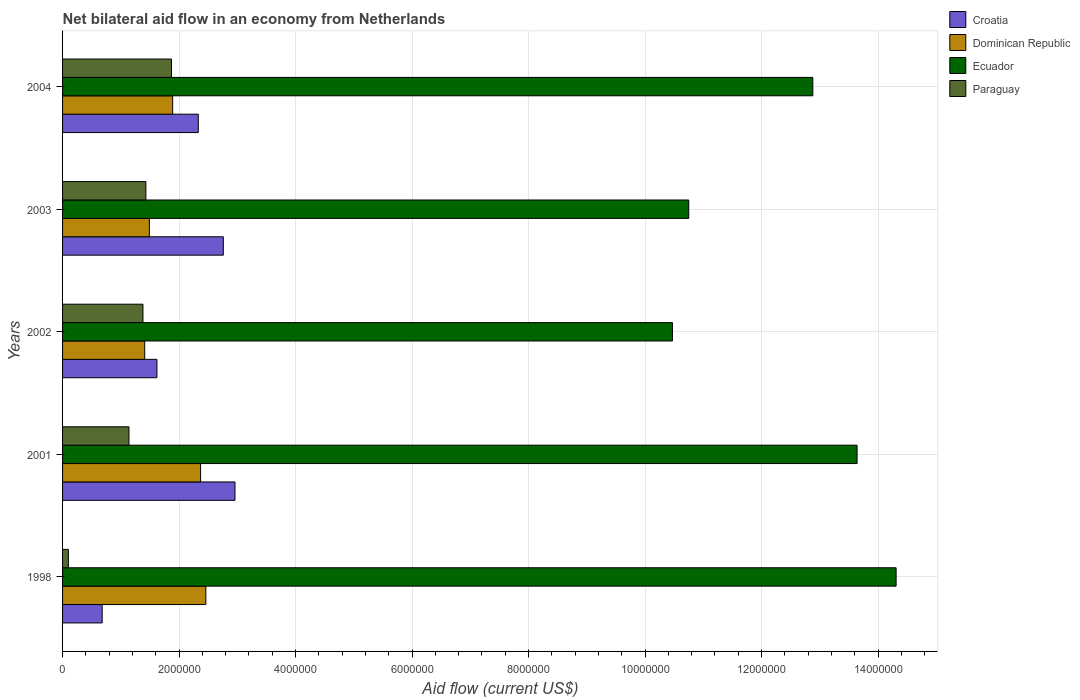How many different coloured bars are there?
Your response must be concise. 4. Are the number of bars per tick equal to the number of legend labels?
Your answer should be very brief. Yes. How many bars are there on the 5th tick from the bottom?
Give a very brief answer. 4. What is the net bilateral aid flow in Paraguay in 2004?
Provide a succinct answer. 1.87e+06. Across all years, what is the maximum net bilateral aid flow in Croatia?
Offer a terse response. 2.96e+06. Across all years, what is the minimum net bilateral aid flow in Dominican Republic?
Keep it short and to the point. 1.41e+06. In which year was the net bilateral aid flow in Ecuador maximum?
Offer a terse response. 1998. What is the total net bilateral aid flow in Ecuador in the graph?
Provide a short and direct response. 6.20e+07. What is the difference between the net bilateral aid flow in Paraguay in 1998 and that in 2003?
Your answer should be very brief. -1.33e+06. What is the difference between the net bilateral aid flow in Ecuador in 1998 and the net bilateral aid flow in Croatia in 2002?
Your answer should be very brief. 1.27e+07. What is the average net bilateral aid flow in Ecuador per year?
Offer a terse response. 1.24e+07. In the year 1998, what is the difference between the net bilateral aid flow in Paraguay and net bilateral aid flow in Ecuador?
Make the answer very short. -1.42e+07. In how many years, is the net bilateral aid flow in Croatia greater than 6800000 US$?
Offer a very short reply. 0. What is the ratio of the net bilateral aid flow in Croatia in 2003 to that in 2004?
Ensure brevity in your answer.  1.18. Is the net bilateral aid flow in Paraguay in 1998 less than that in 2003?
Your answer should be very brief. Yes. What is the difference between the highest and the second highest net bilateral aid flow in Croatia?
Your answer should be very brief. 2.00e+05. What is the difference between the highest and the lowest net bilateral aid flow in Ecuador?
Offer a terse response. 3.84e+06. In how many years, is the net bilateral aid flow in Ecuador greater than the average net bilateral aid flow in Ecuador taken over all years?
Make the answer very short. 3. Is the sum of the net bilateral aid flow in Croatia in 2001 and 2004 greater than the maximum net bilateral aid flow in Paraguay across all years?
Your answer should be very brief. Yes. What does the 3rd bar from the top in 1998 represents?
Ensure brevity in your answer.  Dominican Republic. What does the 2nd bar from the bottom in 1998 represents?
Offer a terse response. Dominican Republic. Is it the case that in every year, the sum of the net bilateral aid flow in Dominican Republic and net bilateral aid flow in Croatia is greater than the net bilateral aid flow in Paraguay?
Make the answer very short. Yes. Are all the bars in the graph horizontal?
Your response must be concise. Yes. How many years are there in the graph?
Keep it short and to the point. 5. What is the difference between two consecutive major ticks on the X-axis?
Offer a terse response. 2.00e+06. Are the values on the major ticks of X-axis written in scientific E-notation?
Offer a very short reply. No. How are the legend labels stacked?
Your answer should be compact. Vertical. What is the title of the graph?
Make the answer very short. Net bilateral aid flow in an economy from Netherlands. Does "Myanmar" appear as one of the legend labels in the graph?
Your answer should be compact. No. What is the label or title of the Y-axis?
Provide a short and direct response. Years. What is the Aid flow (current US$) in Croatia in 1998?
Your response must be concise. 6.80e+05. What is the Aid flow (current US$) of Dominican Republic in 1998?
Your answer should be very brief. 2.46e+06. What is the Aid flow (current US$) in Ecuador in 1998?
Give a very brief answer. 1.43e+07. What is the Aid flow (current US$) in Croatia in 2001?
Keep it short and to the point. 2.96e+06. What is the Aid flow (current US$) of Dominican Republic in 2001?
Offer a very short reply. 2.37e+06. What is the Aid flow (current US$) in Ecuador in 2001?
Keep it short and to the point. 1.36e+07. What is the Aid flow (current US$) in Paraguay in 2001?
Provide a succinct answer. 1.14e+06. What is the Aid flow (current US$) in Croatia in 2002?
Keep it short and to the point. 1.62e+06. What is the Aid flow (current US$) in Dominican Republic in 2002?
Provide a succinct answer. 1.41e+06. What is the Aid flow (current US$) in Ecuador in 2002?
Your answer should be compact. 1.05e+07. What is the Aid flow (current US$) in Paraguay in 2002?
Provide a short and direct response. 1.38e+06. What is the Aid flow (current US$) of Croatia in 2003?
Give a very brief answer. 2.76e+06. What is the Aid flow (current US$) of Dominican Republic in 2003?
Offer a terse response. 1.49e+06. What is the Aid flow (current US$) in Ecuador in 2003?
Make the answer very short. 1.08e+07. What is the Aid flow (current US$) of Paraguay in 2003?
Provide a short and direct response. 1.43e+06. What is the Aid flow (current US$) of Croatia in 2004?
Your answer should be compact. 2.33e+06. What is the Aid flow (current US$) in Dominican Republic in 2004?
Make the answer very short. 1.89e+06. What is the Aid flow (current US$) in Ecuador in 2004?
Keep it short and to the point. 1.29e+07. What is the Aid flow (current US$) of Paraguay in 2004?
Make the answer very short. 1.87e+06. Across all years, what is the maximum Aid flow (current US$) of Croatia?
Your answer should be compact. 2.96e+06. Across all years, what is the maximum Aid flow (current US$) in Dominican Republic?
Give a very brief answer. 2.46e+06. Across all years, what is the maximum Aid flow (current US$) of Ecuador?
Give a very brief answer. 1.43e+07. Across all years, what is the maximum Aid flow (current US$) in Paraguay?
Make the answer very short. 1.87e+06. Across all years, what is the minimum Aid flow (current US$) of Croatia?
Keep it short and to the point. 6.80e+05. Across all years, what is the minimum Aid flow (current US$) in Dominican Republic?
Your answer should be compact. 1.41e+06. Across all years, what is the minimum Aid flow (current US$) in Ecuador?
Provide a succinct answer. 1.05e+07. What is the total Aid flow (current US$) of Croatia in the graph?
Ensure brevity in your answer.  1.04e+07. What is the total Aid flow (current US$) in Dominican Republic in the graph?
Give a very brief answer. 9.62e+06. What is the total Aid flow (current US$) in Ecuador in the graph?
Provide a succinct answer. 6.20e+07. What is the total Aid flow (current US$) of Paraguay in the graph?
Provide a succinct answer. 5.92e+06. What is the difference between the Aid flow (current US$) in Croatia in 1998 and that in 2001?
Give a very brief answer. -2.28e+06. What is the difference between the Aid flow (current US$) of Ecuador in 1998 and that in 2001?
Make the answer very short. 6.70e+05. What is the difference between the Aid flow (current US$) of Paraguay in 1998 and that in 2001?
Provide a succinct answer. -1.04e+06. What is the difference between the Aid flow (current US$) of Croatia in 1998 and that in 2002?
Your answer should be very brief. -9.40e+05. What is the difference between the Aid flow (current US$) of Dominican Republic in 1998 and that in 2002?
Your answer should be very brief. 1.05e+06. What is the difference between the Aid flow (current US$) of Ecuador in 1998 and that in 2002?
Your response must be concise. 3.84e+06. What is the difference between the Aid flow (current US$) of Paraguay in 1998 and that in 2002?
Offer a terse response. -1.28e+06. What is the difference between the Aid flow (current US$) of Croatia in 1998 and that in 2003?
Offer a very short reply. -2.08e+06. What is the difference between the Aid flow (current US$) of Dominican Republic in 1998 and that in 2003?
Keep it short and to the point. 9.70e+05. What is the difference between the Aid flow (current US$) in Ecuador in 1998 and that in 2003?
Give a very brief answer. 3.56e+06. What is the difference between the Aid flow (current US$) of Paraguay in 1998 and that in 2003?
Your answer should be compact. -1.33e+06. What is the difference between the Aid flow (current US$) of Croatia in 1998 and that in 2004?
Ensure brevity in your answer.  -1.65e+06. What is the difference between the Aid flow (current US$) in Dominican Republic in 1998 and that in 2004?
Offer a very short reply. 5.70e+05. What is the difference between the Aid flow (current US$) in Ecuador in 1998 and that in 2004?
Provide a succinct answer. 1.43e+06. What is the difference between the Aid flow (current US$) in Paraguay in 1998 and that in 2004?
Provide a short and direct response. -1.77e+06. What is the difference between the Aid flow (current US$) of Croatia in 2001 and that in 2002?
Your response must be concise. 1.34e+06. What is the difference between the Aid flow (current US$) in Dominican Republic in 2001 and that in 2002?
Provide a short and direct response. 9.60e+05. What is the difference between the Aid flow (current US$) of Ecuador in 2001 and that in 2002?
Give a very brief answer. 3.17e+06. What is the difference between the Aid flow (current US$) in Dominican Republic in 2001 and that in 2003?
Make the answer very short. 8.80e+05. What is the difference between the Aid flow (current US$) of Ecuador in 2001 and that in 2003?
Provide a short and direct response. 2.89e+06. What is the difference between the Aid flow (current US$) of Croatia in 2001 and that in 2004?
Offer a very short reply. 6.30e+05. What is the difference between the Aid flow (current US$) in Dominican Republic in 2001 and that in 2004?
Ensure brevity in your answer.  4.80e+05. What is the difference between the Aid flow (current US$) of Ecuador in 2001 and that in 2004?
Keep it short and to the point. 7.60e+05. What is the difference between the Aid flow (current US$) in Paraguay in 2001 and that in 2004?
Offer a terse response. -7.30e+05. What is the difference between the Aid flow (current US$) of Croatia in 2002 and that in 2003?
Your response must be concise. -1.14e+06. What is the difference between the Aid flow (current US$) of Ecuador in 2002 and that in 2003?
Offer a terse response. -2.80e+05. What is the difference between the Aid flow (current US$) of Paraguay in 2002 and that in 2003?
Provide a succinct answer. -5.00e+04. What is the difference between the Aid flow (current US$) of Croatia in 2002 and that in 2004?
Your answer should be very brief. -7.10e+05. What is the difference between the Aid flow (current US$) in Dominican Republic in 2002 and that in 2004?
Your answer should be very brief. -4.80e+05. What is the difference between the Aid flow (current US$) of Ecuador in 2002 and that in 2004?
Offer a very short reply. -2.41e+06. What is the difference between the Aid flow (current US$) in Paraguay in 2002 and that in 2004?
Provide a succinct answer. -4.90e+05. What is the difference between the Aid flow (current US$) of Dominican Republic in 2003 and that in 2004?
Provide a succinct answer. -4.00e+05. What is the difference between the Aid flow (current US$) of Ecuador in 2003 and that in 2004?
Provide a succinct answer. -2.13e+06. What is the difference between the Aid flow (current US$) of Paraguay in 2003 and that in 2004?
Give a very brief answer. -4.40e+05. What is the difference between the Aid flow (current US$) in Croatia in 1998 and the Aid flow (current US$) in Dominican Republic in 2001?
Give a very brief answer. -1.69e+06. What is the difference between the Aid flow (current US$) of Croatia in 1998 and the Aid flow (current US$) of Ecuador in 2001?
Offer a terse response. -1.30e+07. What is the difference between the Aid flow (current US$) of Croatia in 1998 and the Aid flow (current US$) of Paraguay in 2001?
Your answer should be very brief. -4.60e+05. What is the difference between the Aid flow (current US$) in Dominican Republic in 1998 and the Aid flow (current US$) in Ecuador in 2001?
Provide a succinct answer. -1.12e+07. What is the difference between the Aid flow (current US$) of Dominican Republic in 1998 and the Aid flow (current US$) of Paraguay in 2001?
Provide a succinct answer. 1.32e+06. What is the difference between the Aid flow (current US$) of Ecuador in 1998 and the Aid flow (current US$) of Paraguay in 2001?
Offer a terse response. 1.32e+07. What is the difference between the Aid flow (current US$) of Croatia in 1998 and the Aid flow (current US$) of Dominican Republic in 2002?
Your answer should be compact. -7.30e+05. What is the difference between the Aid flow (current US$) in Croatia in 1998 and the Aid flow (current US$) in Ecuador in 2002?
Give a very brief answer. -9.79e+06. What is the difference between the Aid flow (current US$) of Croatia in 1998 and the Aid flow (current US$) of Paraguay in 2002?
Make the answer very short. -7.00e+05. What is the difference between the Aid flow (current US$) in Dominican Republic in 1998 and the Aid flow (current US$) in Ecuador in 2002?
Provide a short and direct response. -8.01e+06. What is the difference between the Aid flow (current US$) in Dominican Republic in 1998 and the Aid flow (current US$) in Paraguay in 2002?
Give a very brief answer. 1.08e+06. What is the difference between the Aid flow (current US$) in Ecuador in 1998 and the Aid flow (current US$) in Paraguay in 2002?
Provide a short and direct response. 1.29e+07. What is the difference between the Aid flow (current US$) in Croatia in 1998 and the Aid flow (current US$) in Dominican Republic in 2003?
Your response must be concise. -8.10e+05. What is the difference between the Aid flow (current US$) in Croatia in 1998 and the Aid flow (current US$) in Ecuador in 2003?
Provide a short and direct response. -1.01e+07. What is the difference between the Aid flow (current US$) of Croatia in 1998 and the Aid flow (current US$) of Paraguay in 2003?
Your response must be concise. -7.50e+05. What is the difference between the Aid flow (current US$) of Dominican Republic in 1998 and the Aid flow (current US$) of Ecuador in 2003?
Offer a very short reply. -8.29e+06. What is the difference between the Aid flow (current US$) of Dominican Republic in 1998 and the Aid flow (current US$) of Paraguay in 2003?
Your response must be concise. 1.03e+06. What is the difference between the Aid flow (current US$) of Ecuador in 1998 and the Aid flow (current US$) of Paraguay in 2003?
Provide a short and direct response. 1.29e+07. What is the difference between the Aid flow (current US$) in Croatia in 1998 and the Aid flow (current US$) in Dominican Republic in 2004?
Ensure brevity in your answer.  -1.21e+06. What is the difference between the Aid flow (current US$) in Croatia in 1998 and the Aid flow (current US$) in Ecuador in 2004?
Offer a very short reply. -1.22e+07. What is the difference between the Aid flow (current US$) of Croatia in 1998 and the Aid flow (current US$) of Paraguay in 2004?
Your answer should be compact. -1.19e+06. What is the difference between the Aid flow (current US$) in Dominican Republic in 1998 and the Aid flow (current US$) in Ecuador in 2004?
Give a very brief answer. -1.04e+07. What is the difference between the Aid flow (current US$) in Dominican Republic in 1998 and the Aid flow (current US$) in Paraguay in 2004?
Your response must be concise. 5.90e+05. What is the difference between the Aid flow (current US$) in Ecuador in 1998 and the Aid flow (current US$) in Paraguay in 2004?
Ensure brevity in your answer.  1.24e+07. What is the difference between the Aid flow (current US$) of Croatia in 2001 and the Aid flow (current US$) of Dominican Republic in 2002?
Ensure brevity in your answer.  1.55e+06. What is the difference between the Aid flow (current US$) of Croatia in 2001 and the Aid flow (current US$) of Ecuador in 2002?
Keep it short and to the point. -7.51e+06. What is the difference between the Aid flow (current US$) in Croatia in 2001 and the Aid flow (current US$) in Paraguay in 2002?
Your answer should be compact. 1.58e+06. What is the difference between the Aid flow (current US$) of Dominican Republic in 2001 and the Aid flow (current US$) of Ecuador in 2002?
Offer a very short reply. -8.10e+06. What is the difference between the Aid flow (current US$) of Dominican Republic in 2001 and the Aid flow (current US$) of Paraguay in 2002?
Provide a succinct answer. 9.90e+05. What is the difference between the Aid flow (current US$) of Ecuador in 2001 and the Aid flow (current US$) of Paraguay in 2002?
Keep it short and to the point. 1.23e+07. What is the difference between the Aid flow (current US$) of Croatia in 2001 and the Aid flow (current US$) of Dominican Republic in 2003?
Keep it short and to the point. 1.47e+06. What is the difference between the Aid flow (current US$) in Croatia in 2001 and the Aid flow (current US$) in Ecuador in 2003?
Your answer should be very brief. -7.79e+06. What is the difference between the Aid flow (current US$) in Croatia in 2001 and the Aid flow (current US$) in Paraguay in 2003?
Your answer should be very brief. 1.53e+06. What is the difference between the Aid flow (current US$) in Dominican Republic in 2001 and the Aid flow (current US$) in Ecuador in 2003?
Your answer should be compact. -8.38e+06. What is the difference between the Aid flow (current US$) of Dominican Republic in 2001 and the Aid flow (current US$) of Paraguay in 2003?
Provide a succinct answer. 9.40e+05. What is the difference between the Aid flow (current US$) of Ecuador in 2001 and the Aid flow (current US$) of Paraguay in 2003?
Ensure brevity in your answer.  1.22e+07. What is the difference between the Aid flow (current US$) of Croatia in 2001 and the Aid flow (current US$) of Dominican Republic in 2004?
Offer a terse response. 1.07e+06. What is the difference between the Aid flow (current US$) of Croatia in 2001 and the Aid flow (current US$) of Ecuador in 2004?
Offer a terse response. -9.92e+06. What is the difference between the Aid flow (current US$) of Croatia in 2001 and the Aid flow (current US$) of Paraguay in 2004?
Ensure brevity in your answer.  1.09e+06. What is the difference between the Aid flow (current US$) of Dominican Republic in 2001 and the Aid flow (current US$) of Ecuador in 2004?
Your response must be concise. -1.05e+07. What is the difference between the Aid flow (current US$) in Ecuador in 2001 and the Aid flow (current US$) in Paraguay in 2004?
Make the answer very short. 1.18e+07. What is the difference between the Aid flow (current US$) in Croatia in 2002 and the Aid flow (current US$) in Ecuador in 2003?
Provide a succinct answer. -9.13e+06. What is the difference between the Aid flow (current US$) of Dominican Republic in 2002 and the Aid flow (current US$) of Ecuador in 2003?
Ensure brevity in your answer.  -9.34e+06. What is the difference between the Aid flow (current US$) of Dominican Republic in 2002 and the Aid flow (current US$) of Paraguay in 2003?
Give a very brief answer. -2.00e+04. What is the difference between the Aid flow (current US$) in Ecuador in 2002 and the Aid flow (current US$) in Paraguay in 2003?
Keep it short and to the point. 9.04e+06. What is the difference between the Aid flow (current US$) of Croatia in 2002 and the Aid flow (current US$) of Dominican Republic in 2004?
Provide a short and direct response. -2.70e+05. What is the difference between the Aid flow (current US$) in Croatia in 2002 and the Aid flow (current US$) in Ecuador in 2004?
Keep it short and to the point. -1.13e+07. What is the difference between the Aid flow (current US$) in Croatia in 2002 and the Aid flow (current US$) in Paraguay in 2004?
Give a very brief answer. -2.50e+05. What is the difference between the Aid flow (current US$) in Dominican Republic in 2002 and the Aid flow (current US$) in Ecuador in 2004?
Your answer should be compact. -1.15e+07. What is the difference between the Aid flow (current US$) in Dominican Republic in 2002 and the Aid flow (current US$) in Paraguay in 2004?
Make the answer very short. -4.60e+05. What is the difference between the Aid flow (current US$) in Ecuador in 2002 and the Aid flow (current US$) in Paraguay in 2004?
Make the answer very short. 8.60e+06. What is the difference between the Aid flow (current US$) in Croatia in 2003 and the Aid flow (current US$) in Dominican Republic in 2004?
Keep it short and to the point. 8.70e+05. What is the difference between the Aid flow (current US$) of Croatia in 2003 and the Aid flow (current US$) of Ecuador in 2004?
Ensure brevity in your answer.  -1.01e+07. What is the difference between the Aid flow (current US$) of Croatia in 2003 and the Aid flow (current US$) of Paraguay in 2004?
Give a very brief answer. 8.90e+05. What is the difference between the Aid flow (current US$) of Dominican Republic in 2003 and the Aid flow (current US$) of Ecuador in 2004?
Your response must be concise. -1.14e+07. What is the difference between the Aid flow (current US$) of Dominican Republic in 2003 and the Aid flow (current US$) of Paraguay in 2004?
Make the answer very short. -3.80e+05. What is the difference between the Aid flow (current US$) in Ecuador in 2003 and the Aid flow (current US$) in Paraguay in 2004?
Keep it short and to the point. 8.88e+06. What is the average Aid flow (current US$) in Croatia per year?
Give a very brief answer. 2.07e+06. What is the average Aid flow (current US$) of Dominican Republic per year?
Your response must be concise. 1.92e+06. What is the average Aid flow (current US$) of Ecuador per year?
Give a very brief answer. 1.24e+07. What is the average Aid flow (current US$) in Paraguay per year?
Give a very brief answer. 1.18e+06. In the year 1998, what is the difference between the Aid flow (current US$) of Croatia and Aid flow (current US$) of Dominican Republic?
Make the answer very short. -1.78e+06. In the year 1998, what is the difference between the Aid flow (current US$) of Croatia and Aid flow (current US$) of Ecuador?
Your answer should be compact. -1.36e+07. In the year 1998, what is the difference between the Aid flow (current US$) in Croatia and Aid flow (current US$) in Paraguay?
Provide a succinct answer. 5.80e+05. In the year 1998, what is the difference between the Aid flow (current US$) of Dominican Republic and Aid flow (current US$) of Ecuador?
Give a very brief answer. -1.18e+07. In the year 1998, what is the difference between the Aid flow (current US$) of Dominican Republic and Aid flow (current US$) of Paraguay?
Offer a terse response. 2.36e+06. In the year 1998, what is the difference between the Aid flow (current US$) in Ecuador and Aid flow (current US$) in Paraguay?
Ensure brevity in your answer.  1.42e+07. In the year 2001, what is the difference between the Aid flow (current US$) in Croatia and Aid flow (current US$) in Dominican Republic?
Your answer should be very brief. 5.90e+05. In the year 2001, what is the difference between the Aid flow (current US$) in Croatia and Aid flow (current US$) in Ecuador?
Provide a short and direct response. -1.07e+07. In the year 2001, what is the difference between the Aid flow (current US$) of Croatia and Aid flow (current US$) of Paraguay?
Keep it short and to the point. 1.82e+06. In the year 2001, what is the difference between the Aid flow (current US$) in Dominican Republic and Aid flow (current US$) in Ecuador?
Your response must be concise. -1.13e+07. In the year 2001, what is the difference between the Aid flow (current US$) in Dominican Republic and Aid flow (current US$) in Paraguay?
Your answer should be compact. 1.23e+06. In the year 2001, what is the difference between the Aid flow (current US$) in Ecuador and Aid flow (current US$) in Paraguay?
Your response must be concise. 1.25e+07. In the year 2002, what is the difference between the Aid flow (current US$) of Croatia and Aid flow (current US$) of Ecuador?
Give a very brief answer. -8.85e+06. In the year 2002, what is the difference between the Aid flow (current US$) of Croatia and Aid flow (current US$) of Paraguay?
Provide a short and direct response. 2.40e+05. In the year 2002, what is the difference between the Aid flow (current US$) of Dominican Republic and Aid flow (current US$) of Ecuador?
Give a very brief answer. -9.06e+06. In the year 2002, what is the difference between the Aid flow (current US$) in Ecuador and Aid flow (current US$) in Paraguay?
Make the answer very short. 9.09e+06. In the year 2003, what is the difference between the Aid flow (current US$) of Croatia and Aid flow (current US$) of Dominican Republic?
Provide a short and direct response. 1.27e+06. In the year 2003, what is the difference between the Aid flow (current US$) of Croatia and Aid flow (current US$) of Ecuador?
Your response must be concise. -7.99e+06. In the year 2003, what is the difference between the Aid flow (current US$) in Croatia and Aid flow (current US$) in Paraguay?
Your answer should be compact. 1.33e+06. In the year 2003, what is the difference between the Aid flow (current US$) in Dominican Republic and Aid flow (current US$) in Ecuador?
Offer a terse response. -9.26e+06. In the year 2003, what is the difference between the Aid flow (current US$) of Ecuador and Aid flow (current US$) of Paraguay?
Offer a terse response. 9.32e+06. In the year 2004, what is the difference between the Aid flow (current US$) in Croatia and Aid flow (current US$) in Dominican Republic?
Give a very brief answer. 4.40e+05. In the year 2004, what is the difference between the Aid flow (current US$) of Croatia and Aid flow (current US$) of Ecuador?
Your answer should be compact. -1.06e+07. In the year 2004, what is the difference between the Aid flow (current US$) of Croatia and Aid flow (current US$) of Paraguay?
Your answer should be compact. 4.60e+05. In the year 2004, what is the difference between the Aid flow (current US$) in Dominican Republic and Aid flow (current US$) in Ecuador?
Provide a succinct answer. -1.10e+07. In the year 2004, what is the difference between the Aid flow (current US$) in Dominican Republic and Aid flow (current US$) in Paraguay?
Ensure brevity in your answer.  2.00e+04. In the year 2004, what is the difference between the Aid flow (current US$) in Ecuador and Aid flow (current US$) in Paraguay?
Offer a terse response. 1.10e+07. What is the ratio of the Aid flow (current US$) in Croatia in 1998 to that in 2001?
Provide a short and direct response. 0.23. What is the ratio of the Aid flow (current US$) of Dominican Republic in 1998 to that in 2001?
Your answer should be compact. 1.04. What is the ratio of the Aid flow (current US$) of Ecuador in 1998 to that in 2001?
Provide a short and direct response. 1.05. What is the ratio of the Aid flow (current US$) in Paraguay in 1998 to that in 2001?
Provide a succinct answer. 0.09. What is the ratio of the Aid flow (current US$) of Croatia in 1998 to that in 2002?
Your answer should be compact. 0.42. What is the ratio of the Aid flow (current US$) of Dominican Republic in 1998 to that in 2002?
Give a very brief answer. 1.74. What is the ratio of the Aid flow (current US$) in Ecuador in 1998 to that in 2002?
Offer a very short reply. 1.37. What is the ratio of the Aid flow (current US$) in Paraguay in 1998 to that in 2002?
Your answer should be compact. 0.07. What is the ratio of the Aid flow (current US$) in Croatia in 1998 to that in 2003?
Keep it short and to the point. 0.25. What is the ratio of the Aid flow (current US$) in Dominican Republic in 1998 to that in 2003?
Your answer should be compact. 1.65. What is the ratio of the Aid flow (current US$) in Ecuador in 1998 to that in 2003?
Ensure brevity in your answer.  1.33. What is the ratio of the Aid flow (current US$) of Paraguay in 1998 to that in 2003?
Make the answer very short. 0.07. What is the ratio of the Aid flow (current US$) of Croatia in 1998 to that in 2004?
Your response must be concise. 0.29. What is the ratio of the Aid flow (current US$) of Dominican Republic in 1998 to that in 2004?
Provide a succinct answer. 1.3. What is the ratio of the Aid flow (current US$) in Ecuador in 1998 to that in 2004?
Your response must be concise. 1.11. What is the ratio of the Aid flow (current US$) in Paraguay in 1998 to that in 2004?
Provide a succinct answer. 0.05. What is the ratio of the Aid flow (current US$) of Croatia in 2001 to that in 2002?
Your answer should be very brief. 1.83. What is the ratio of the Aid flow (current US$) of Dominican Republic in 2001 to that in 2002?
Make the answer very short. 1.68. What is the ratio of the Aid flow (current US$) in Ecuador in 2001 to that in 2002?
Provide a short and direct response. 1.3. What is the ratio of the Aid flow (current US$) in Paraguay in 2001 to that in 2002?
Your answer should be compact. 0.83. What is the ratio of the Aid flow (current US$) of Croatia in 2001 to that in 2003?
Provide a succinct answer. 1.07. What is the ratio of the Aid flow (current US$) of Dominican Republic in 2001 to that in 2003?
Give a very brief answer. 1.59. What is the ratio of the Aid flow (current US$) in Ecuador in 2001 to that in 2003?
Your answer should be very brief. 1.27. What is the ratio of the Aid flow (current US$) in Paraguay in 2001 to that in 2003?
Your answer should be very brief. 0.8. What is the ratio of the Aid flow (current US$) in Croatia in 2001 to that in 2004?
Provide a short and direct response. 1.27. What is the ratio of the Aid flow (current US$) of Dominican Republic in 2001 to that in 2004?
Your response must be concise. 1.25. What is the ratio of the Aid flow (current US$) of Ecuador in 2001 to that in 2004?
Keep it short and to the point. 1.06. What is the ratio of the Aid flow (current US$) of Paraguay in 2001 to that in 2004?
Your response must be concise. 0.61. What is the ratio of the Aid flow (current US$) of Croatia in 2002 to that in 2003?
Your answer should be very brief. 0.59. What is the ratio of the Aid flow (current US$) in Dominican Republic in 2002 to that in 2003?
Provide a short and direct response. 0.95. What is the ratio of the Aid flow (current US$) in Ecuador in 2002 to that in 2003?
Offer a very short reply. 0.97. What is the ratio of the Aid flow (current US$) of Croatia in 2002 to that in 2004?
Keep it short and to the point. 0.7. What is the ratio of the Aid flow (current US$) of Dominican Republic in 2002 to that in 2004?
Give a very brief answer. 0.75. What is the ratio of the Aid flow (current US$) in Ecuador in 2002 to that in 2004?
Ensure brevity in your answer.  0.81. What is the ratio of the Aid flow (current US$) in Paraguay in 2002 to that in 2004?
Keep it short and to the point. 0.74. What is the ratio of the Aid flow (current US$) in Croatia in 2003 to that in 2004?
Your answer should be very brief. 1.18. What is the ratio of the Aid flow (current US$) of Dominican Republic in 2003 to that in 2004?
Offer a very short reply. 0.79. What is the ratio of the Aid flow (current US$) in Ecuador in 2003 to that in 2004?
Offer a terse response. 0.83. What is the ratio of the Aid flow (current US$) in Paraguay in 2003 to that in 2004?
Make the answer very short. 0.76. What is the difference between the highest and the second highest Aid flow (current US$) in Croatia?
Your answer should be very brief. 2.00e+05. What is the difference between the highest and the second highest Aid flow (current US$) in Ecuador?
Provide a short and direct response. 6.70e+05. What is the difference between the highest and the second highest Aid flow (current US$) in Paraguay?
Provide a succinct answer. 4.40e+05. What is the difference between the highest and the lowest Aid flow (current US$) of Croatia?
Give a very brief answer. 2.28e+06. What is the difference between the highest and the lowest Aid flow (current US$) of Dominican Republic?
Offer a terse response. 1.05e+06. What is the difference between the highest and the lowest Aid flow (current US$) of Ecuador?
Your response must be concise. 3.84e+06. What is the difference between the highest and the lowest Aid flow (current US$) in Paraguay?
Make the answer very short. 1.77e+06. 